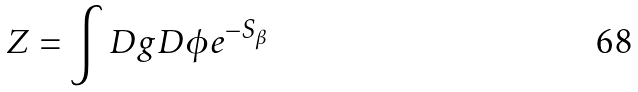Convert formula to latex. <formula><loc_0><loc_0><loc_500><loc_500>Z = \int D g D \phi e ^ { - S _ { \beta } }</formula> 